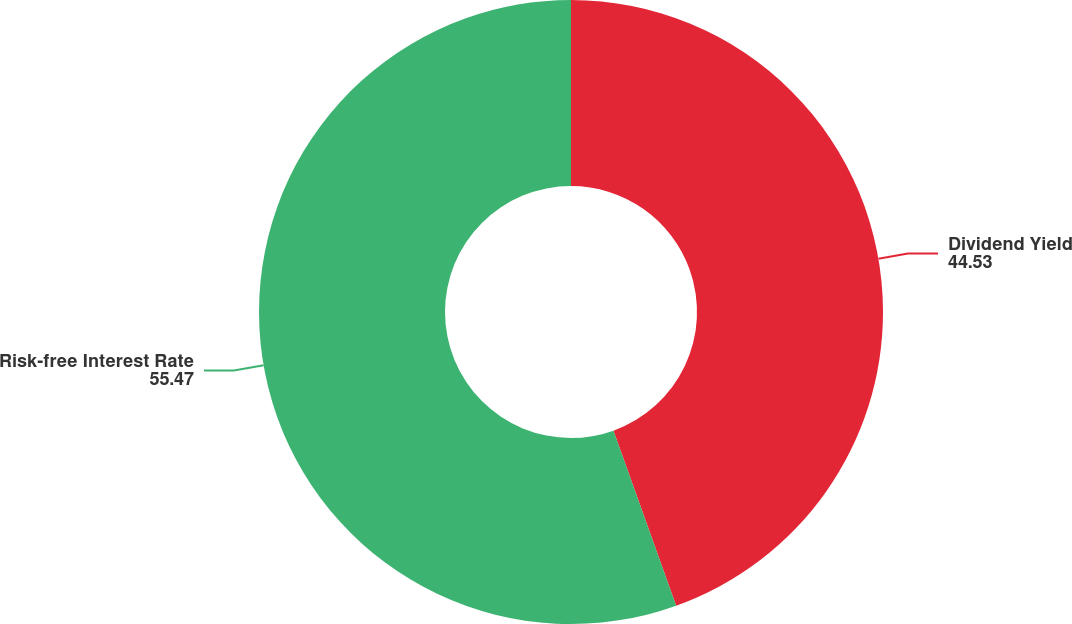Convert chart. <chart><loc_0><loc_0><loc_500><loc_500><pie_chart><fcel>Dividend Yield<fcel>Risk-free Interest Rate<nl><fcel>44.53%<fcel>55.47%<nl></chart> 